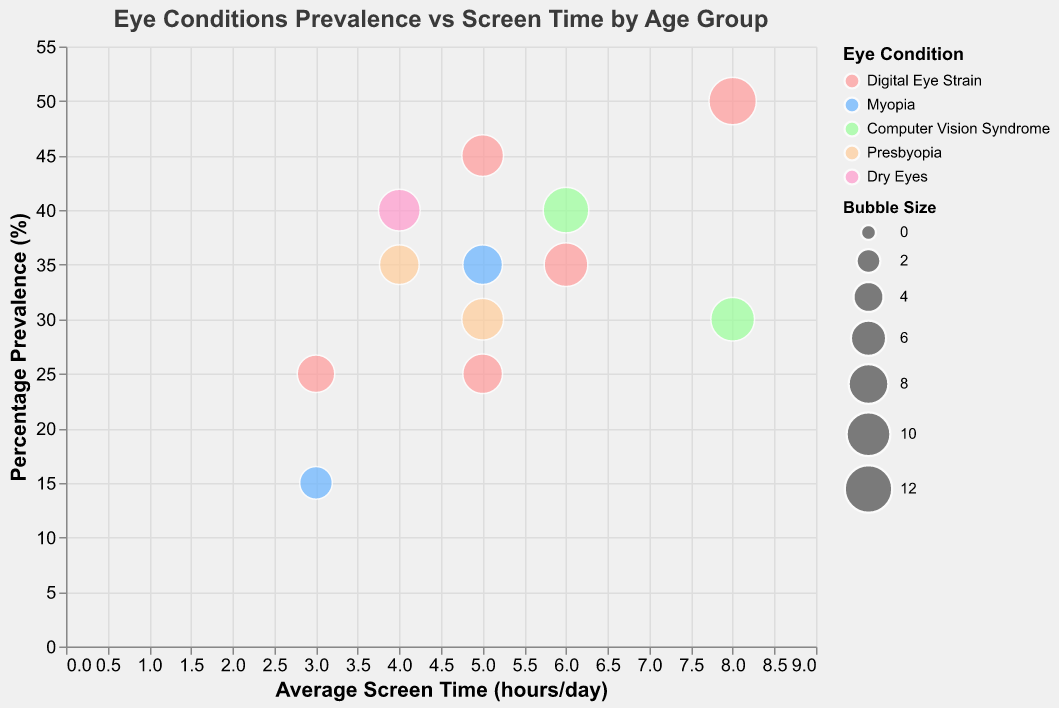What is the title of the figure? The title of the figure is displayed at the top and provides a summary of what the chart represents: "Eye Conditions Prevalence vs Screen Time by Age Group."
Answer: Eye Conditions Prevalence vs Screen Time by Age Group Which age group has the highest percentage prevalence of Digital Eye Strain? By looking at the y-axis (Percentage Prevalence) and the color that represents "Digital Eye Strain," the 19-29 age group shows the highest value at 50%.
Answer: 19-29 What is the average screen time per day for the 13-18 age group? According to the x-axis (Average Screen Time in hrs/day) and the tooltip, the data points for the 13-18 age group show an average screen time of 5 hours per day.
Answer: 5 hrs/day Which eye condition has the largest bubble size in the figure? Bubble size is correlated with "Bubble Size" field. The largest bubble size in the chart corresponds to Digital Eye Strain in the 19-29 age group with a size of 12.
Answer: Digital Eye Strain Compare the percentage prevalence of Myopia between the 0-12 and 13-18 age groups. Which age group has a higher prevalence? Checking the y-axis values for Myopia in both groups, 13-18 has a higher prevalence (35%) compared to the 0-12 age group (15%).
Answer: 13-18 Which condition is more prevalent in the 61+ age group, Dry Eyes or Presbyopia? For the 61+ age group, the y-axis values indicate that Dry Eyes (40%) is more prevalent than Presbyopia (35%).
Answer: Dry Eyes What is the difference in average screen time between the 19-29 and the 0-12 age groups for Digital Eye Strain? The average screen time for Digital Eye Strain in the 19-29 age group is 8 hrs/day, and for the 0-12 age group, it is 3 hrs/day. The difference is 8 - 3 = 5 hrs/day.
Answer: 5 hrs/day Identify the age group with the lowest percentage prevalence of Myopia. The y-axis values show that the 0-12 age group has the lowest prevalence of Myopia at 15%.
Answer: 0-12 How does the prevalence of Computer Vision Syndrome compare between the age groups 19-29 and 30-45? For Computer Vision Syndrome, the y-axis indicates a prevalence of 30% for the 19-29 age group and 40% for the 30-45 age group. The 30-45 age group has a higher prevalence.
Answer: 30-45 What is the combined prevalence percentage of Presbyopia in the 46-60 and 61+ age groups? The y-axis values show a prevalence of 30% for 46-60 and 35% for 61+. Combining them is 30 + 35 = 65%.
Answer: 65% 